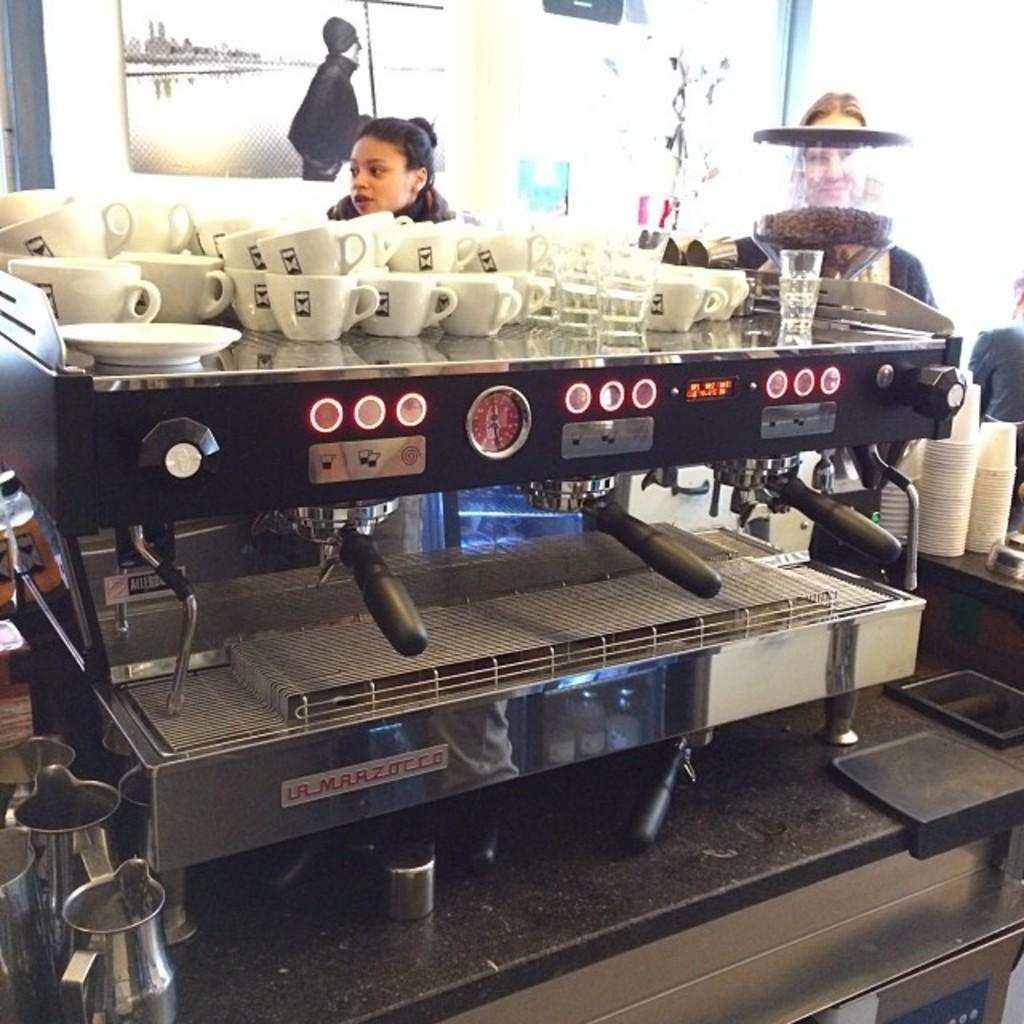<image>
Share a concise interpretation of the image provided. The brand of the coffee machine is La Marzocco. 